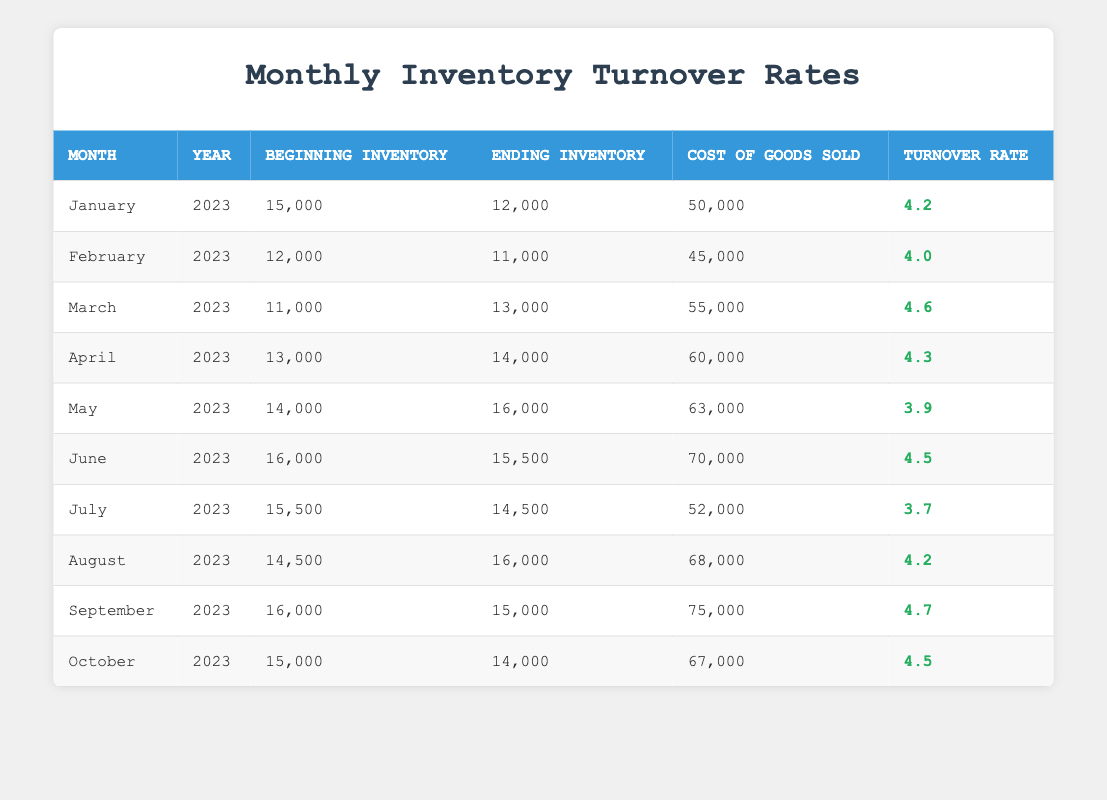What was the beginning inventory for February 2023? The table shows that the beginning inventory for February 2023 is listed under the corresponding month and year, which states "12,000."
Answer: 12,000 What is the turnover rate for June 2023? By looking at the row for June 2023 in the table, the turnover rate is provided as "4.5."
Answer: 4.5 How many months had a turnover rate higher than 4.0? We need to check each month's turnover rate in the table. The rates higher than 4.0 are January (4.2), March (4.6), April (4.3), June (4.5), August (4.2), September (4.7), and October (4.5). Counting these gives us a total of 7 months.
Answer: 7 What is the difference in turnover rate between March 2023 and May 2023? The turnover rate for March 2023 is 4.6, and for May 2023, it is 3.9. We subtract to find the difference: 4.6 - 3.9 = 0.7.
Answer: 0.7 Is the ending inventory for April 2023 equal to the beginning inventory for May 2023? The table indicates that the ending inventory for April 2023 is "14,000", while the beginning inventory for May 2023 is "14,000". Since both values are the same, the statement is true.
Answer: Yes What was the average cost of goods sold for the months from January to March 2023? We sum the cost of goods sold for January (50,000), February (45,000), and March (55,000): 50,000 + 45,000 + 55,000 = 150,000. Then we divide by 3 (the number of months): 150,000 / 3 = 50,000.
Answer: 50,000 In which month did the ending inventory decrease compared to the beginning inventory? By examining the table, we see that in May 2023 the beginning inventory is 14,000 and the ending inventory is 16,000 (an increase), and in July 2023, beginning inventory was 15,500 and ending inventory decreased to 14,500. This indicates a decrease occurred in July.
Answer: July How many months had a turnover rate of 4.5 or higher? We check the turnover rates for each month: January (4.2), February (4.0), March (4.6), April (4.3), May (3.9), June (4.5), July (3.7), August (4.2), September (4.7), October (4.5). The months meeting the criteria are March, June, September, and October. Count these gives us a total of 4 months.
Answer: 4 